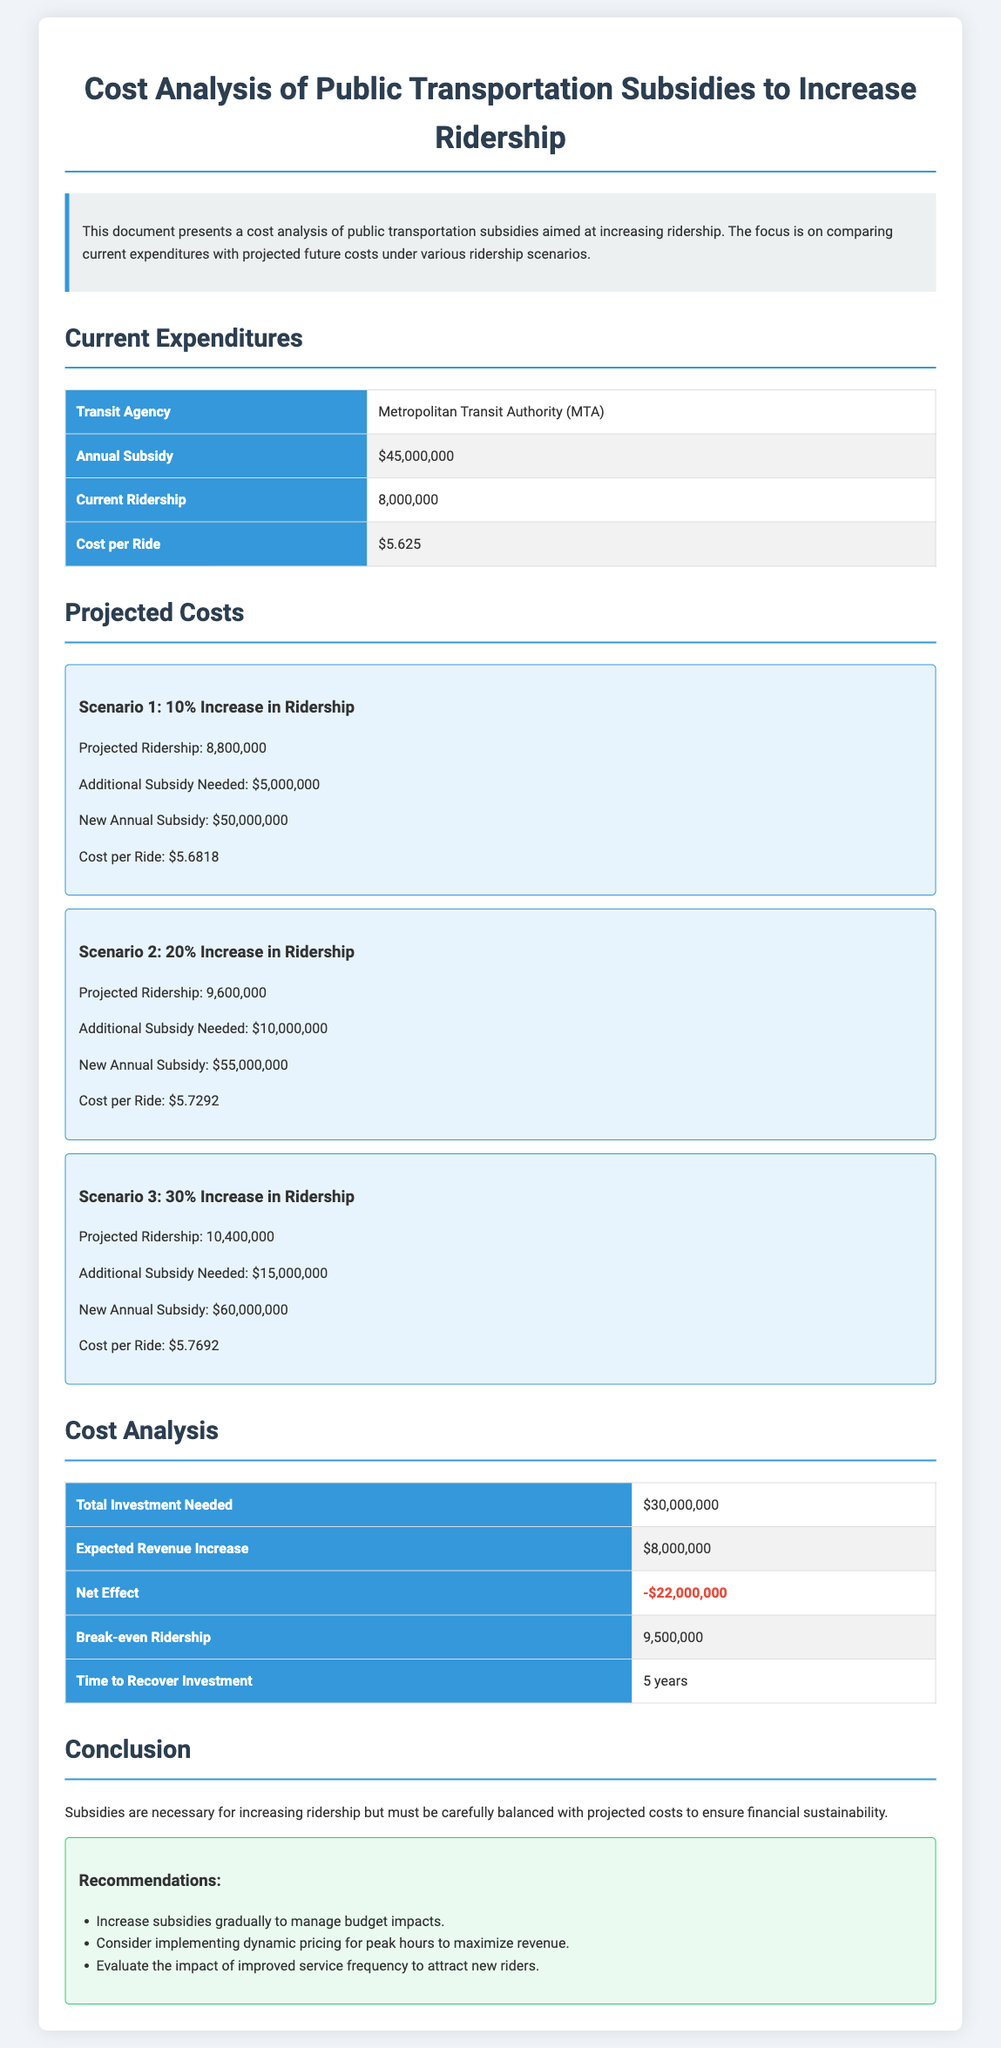What is the annual subsidy for the MTA? The annual subsidy for the MTA is stated in the document as $45,000,000.
Answer: $45,000,000 What is the current ridership figure? The document provides the current ridership figure as 8,000,000.
Answer: 8,000,000 What is the projected ridership in Scenario 2? The projected ridership in Scenario 2 is 9,600,000, as mentioned in the scenario details.
Answer: 9,600,000 What is the additional subsidy needed in Scenario 3? The additional subsidy needed in Scenario 3 is $15,000,000, according to the projected costs.
Answer: $15,000,000 What is the net effect of the investment? The net effect of the investment is outlined as -$22,000,000 in the cost analysis section.
Answer: -$22,000,000 What is the break-even ridership number? The break-even ridership number is specified as 9,500,000 in the cost analysis.
Answer: 9,500,000 How long is the time to recover investment? The document indicates that the time to recover investment is 5 years.
Answer: 5 years What is the expected revenue increase? The expected revenue increase is mentioned as $8,000,000 in the cost analysis table.
Answer: $8,000,000 What is the cost per ride in Scenario 1? The cost per ride in Scenario 1 is calculated as $5.6818, detailed in the scenario description.
Answer: $5.6818 